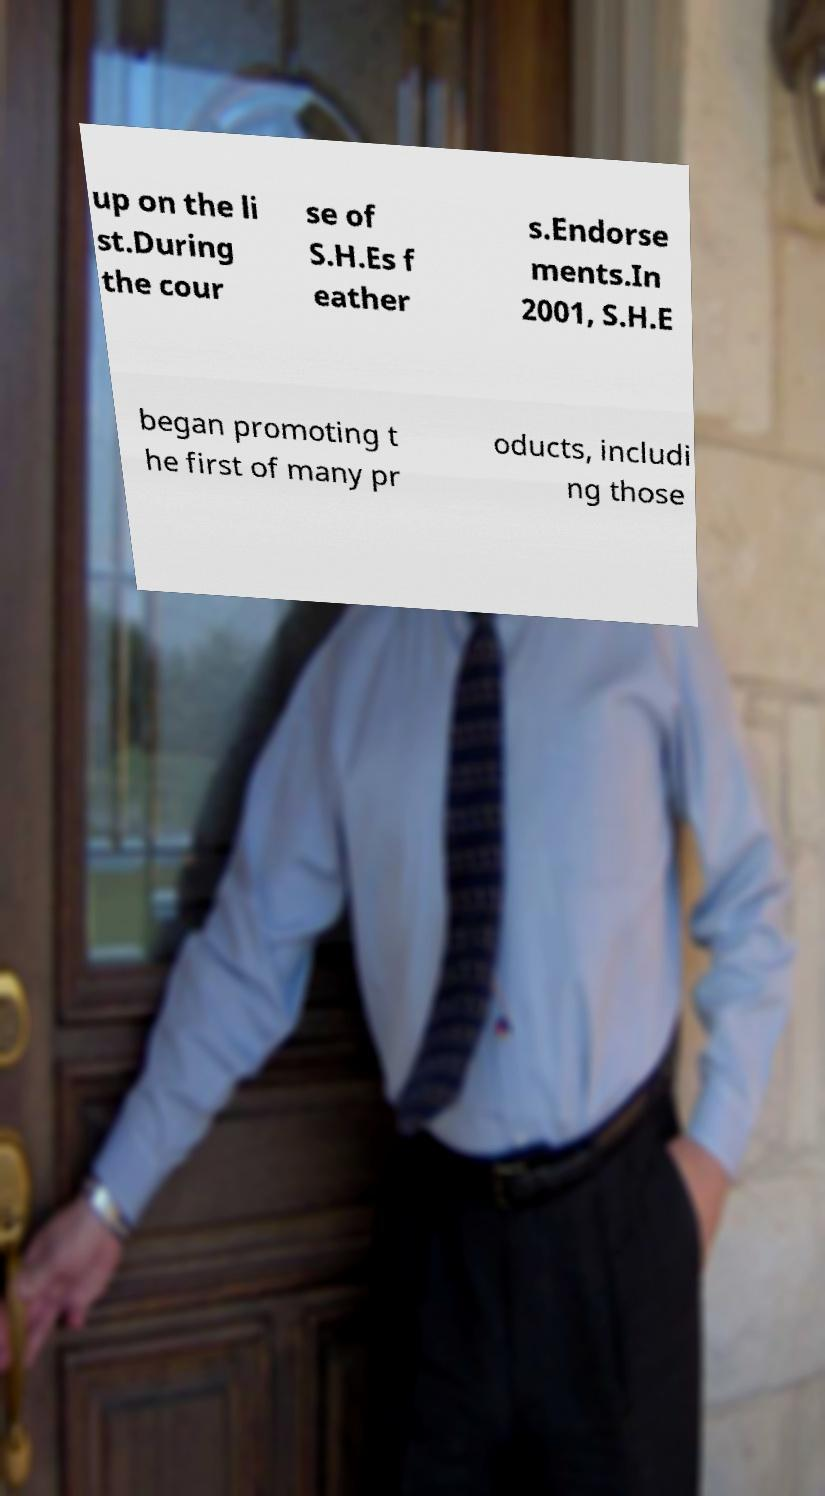Can you read and provide the text displayed in the image?This photo seems to have some interesting text. Can you extract and type it out for me? up on the li st.During the cour se of S.H.Es f eather s.Endorse ments.In 2001, S.H.E began promoting t he first of many pr oducts, includi ng those 